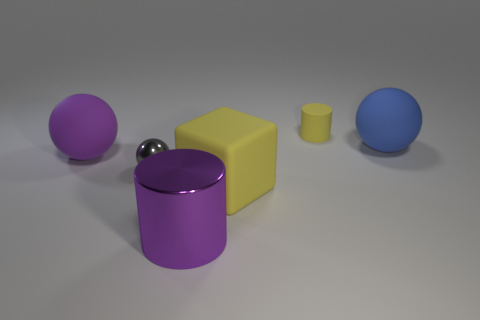Add 3 blue matte balls. How many objects exist? 9 Subtract all cylinders. How many objects are left? 4 Subtract all blue matte balls. Subtract all rubber cylinders. How many objects are left? 4 Add 6 tiny yellow rubber things. How many tiny yellow rubber things are left? 7 Add 1 small yellow things. How many small yellow things exist? 2 Subtract 0 green cubes. How many objects are left? 6 